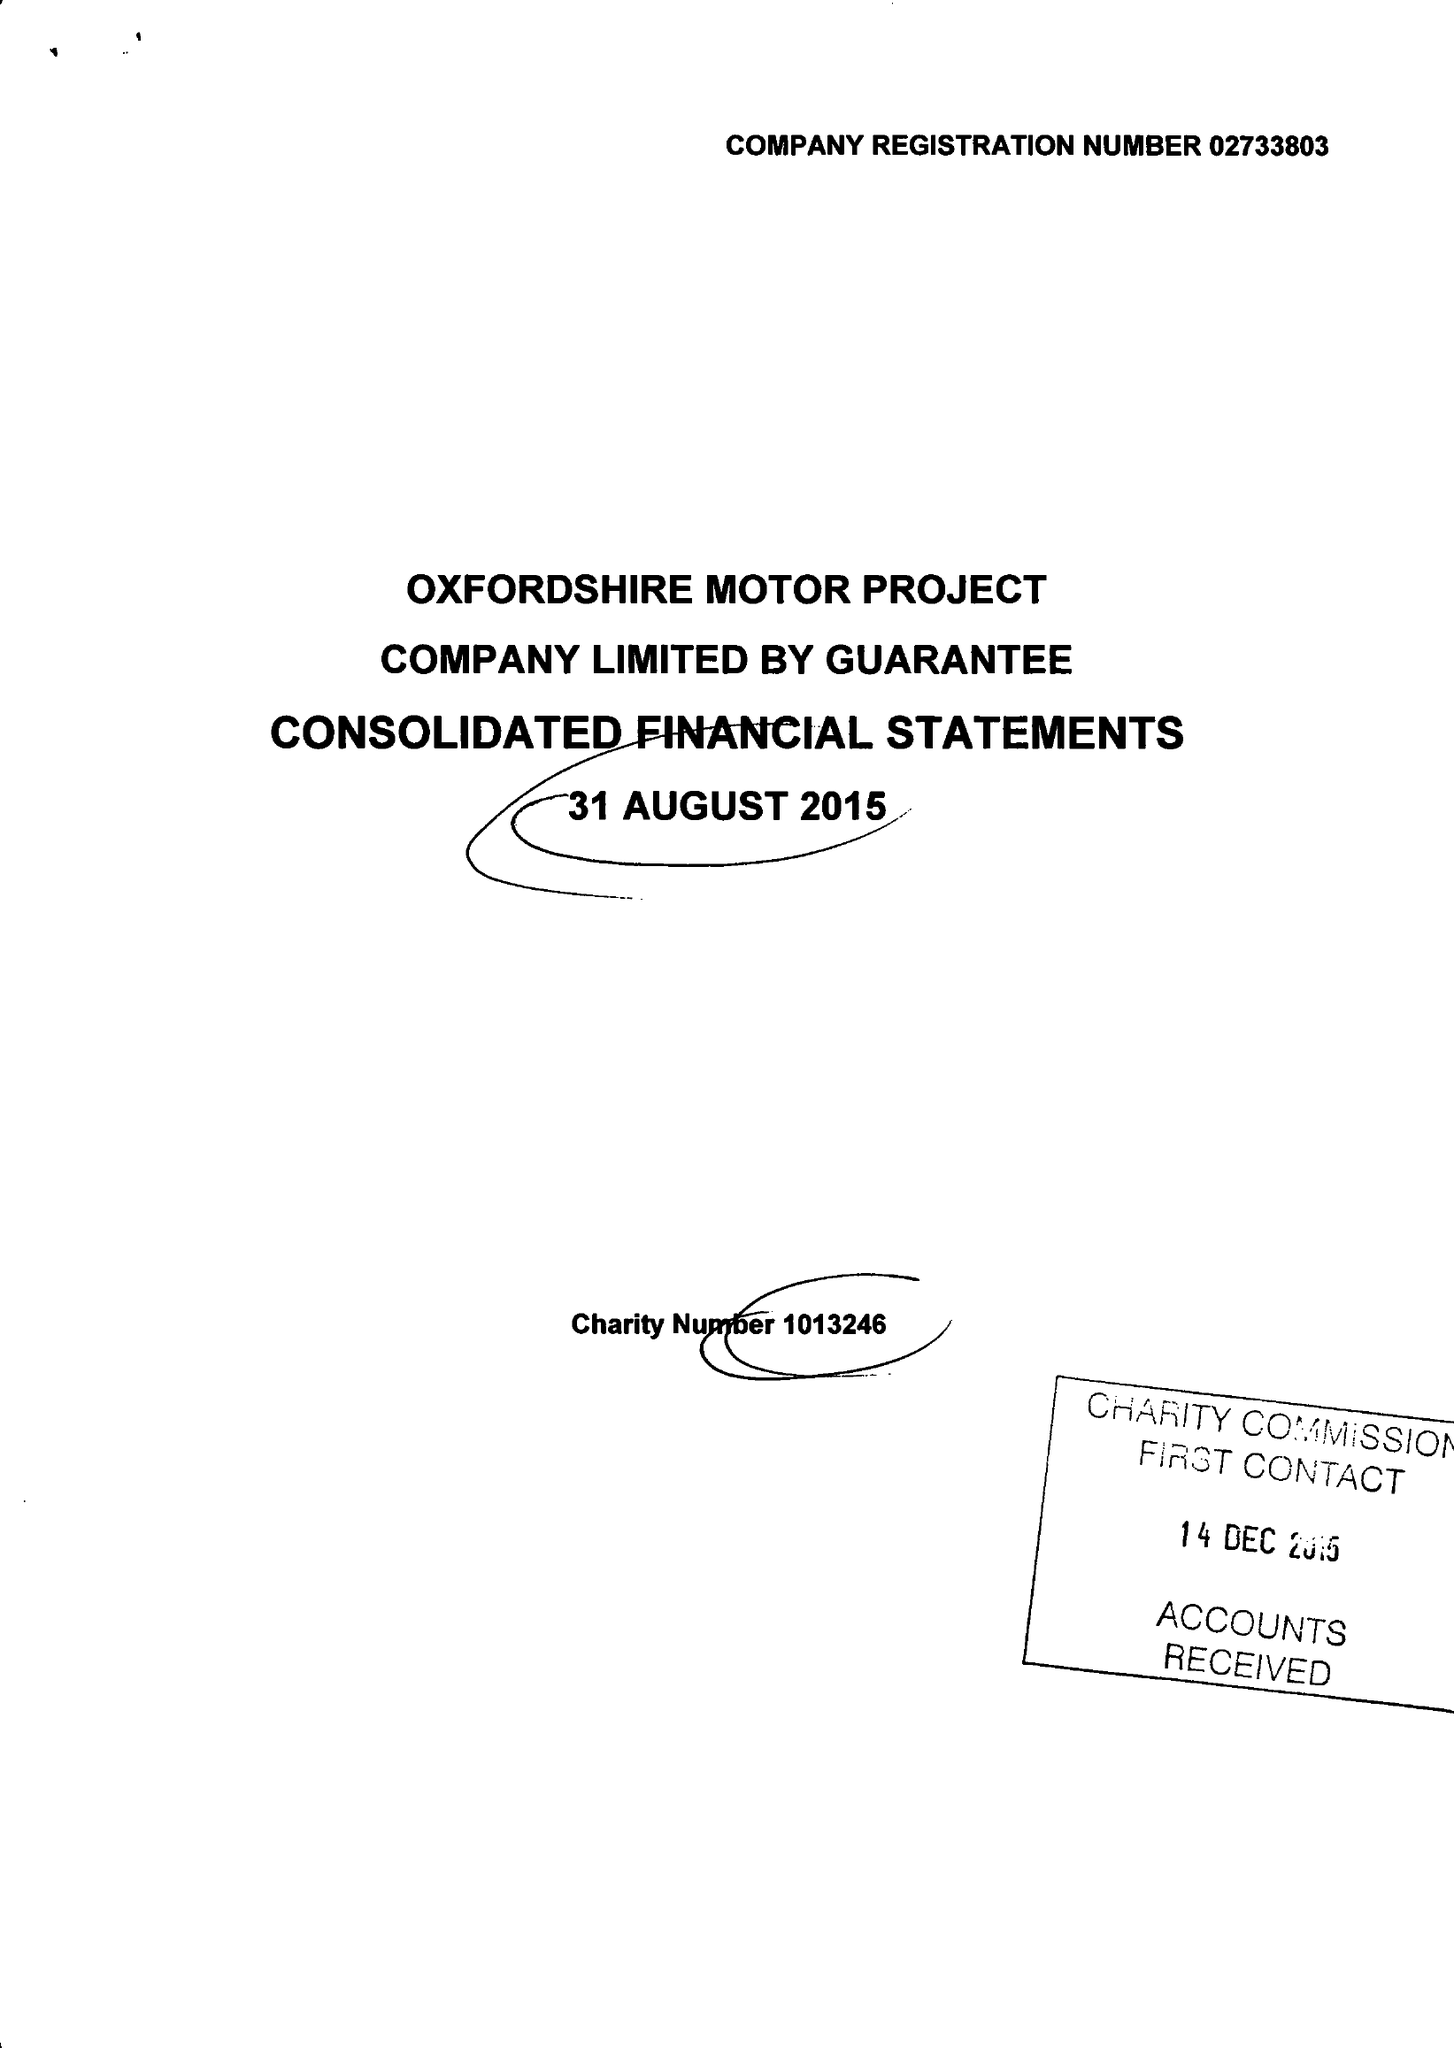What is the value for the spending_annually_in_british_pounds?
Answer the question using a single word or phrase. 481778.00 